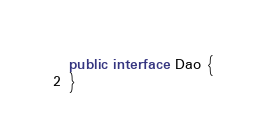Convert code to text. <code><loc_0><loc_0><loc_500><loc_500><_Java_>
public interface Dao {
}
</code> 